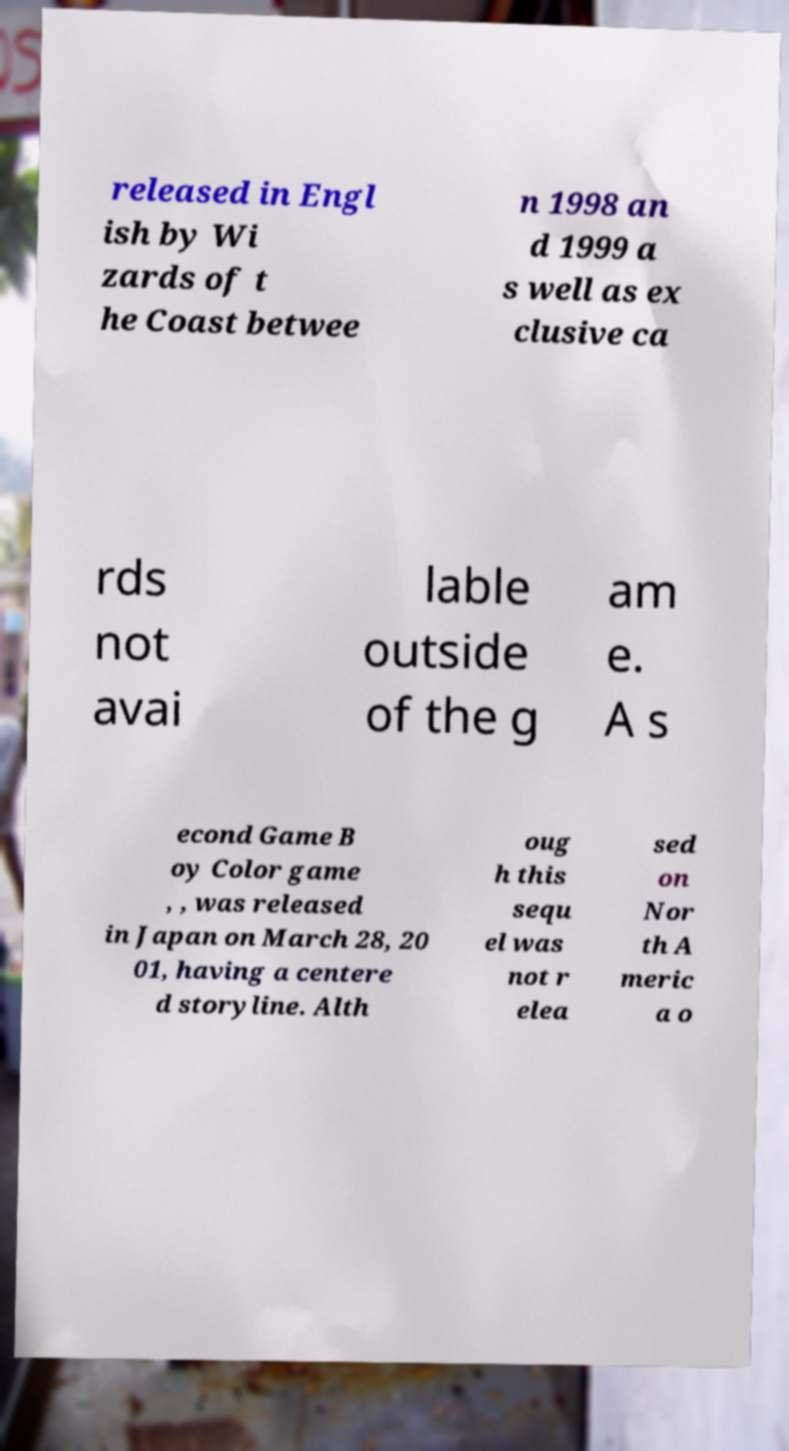Could you assist in decoding the text presented in this image and type it out clearly? released in Engl ish by Wi zards of t he Coast betwee n 1998 an d 1999 a s well as ex clusive ca rds not avai lable outside of the g am e. A s econd Game B oy Color game , , was released in Japan on March 28, 20 01, having a centere d storyline. Alth oug h this sequ el was not r elea sed on Nor th A meric a o 